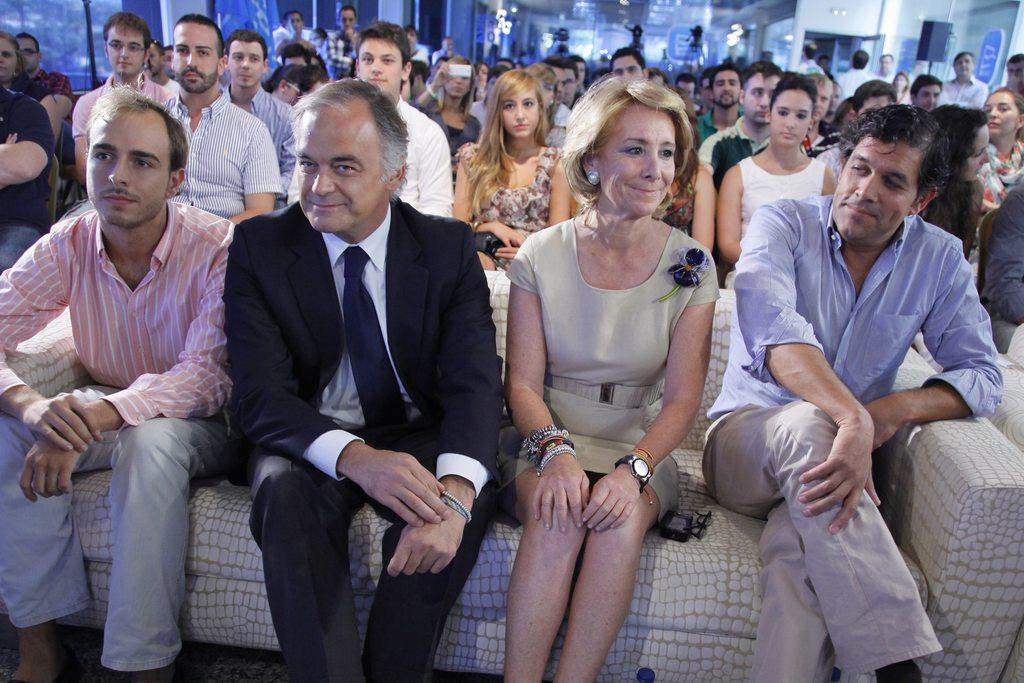How many people are sitting on the couch in the image? There are four people sitting on the couch in the image. What other seating arrangement can be seen in the image? There are other people sitting on chairs. What can be observed in the background of the image? There are blurred things in the background. What type of button is being used by the band in the image? There is no band or button present in the image. What kind of yam dish is being served to the people in the image? There is no yam dish or any food visible in the image. 